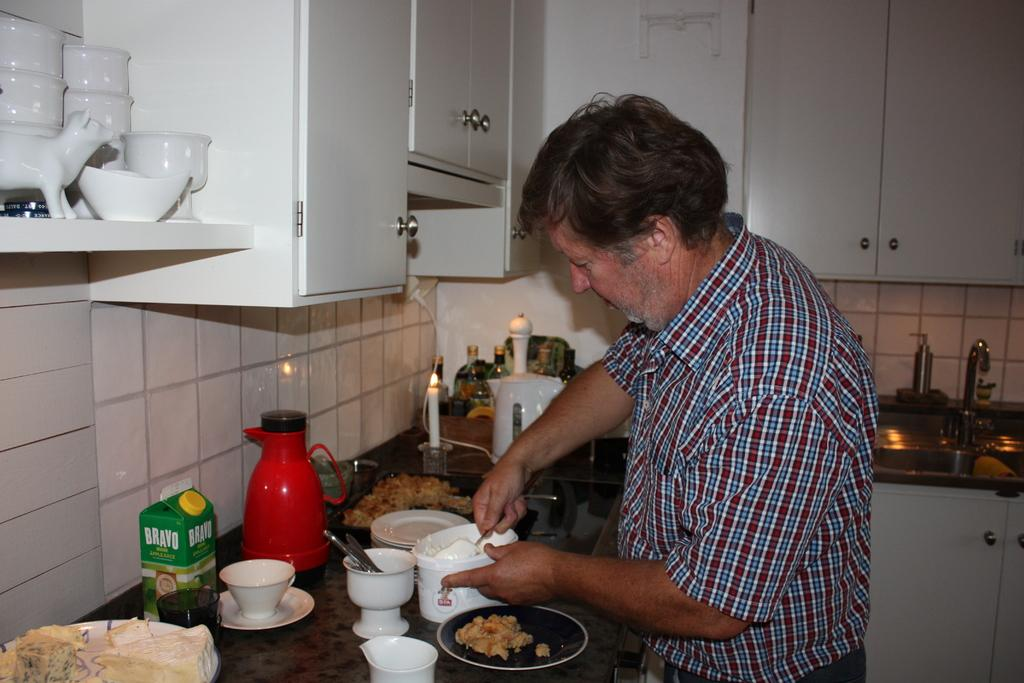<image>
Share a concise interpretation of the image provided. A man cooking in a kitchen where a green BRAVO carton box nearby. 